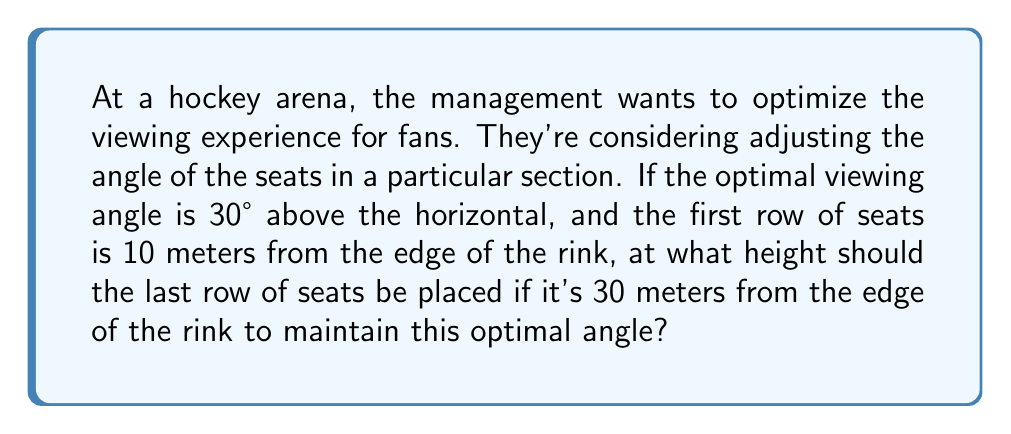Provide a solution to this math problem. Let's approach this step-by-step:

1) We can model this situation using a right triangle, where:
   - The base of the triangle is the horizontal distance from the first row to the last row
   - The height of the triangle is the vertical distance we're trying to find
   - The angle between the base and the hypotenuse is our optimal viewing angle

2) We know:
   - The optimal angle is 30°
   - The distance from the rink to the first row is 10 meters
   - The distance from the rink to the last row is 30 meters

3) The length of the base of our triangle is:
   $30 - 10 = 20$ meters

4) We can use the tangent function to find the height. In a right triangle:

   $\tan(\theta) = \frac{\text{opposite}}{\text{adjacent}} = \frac{\text{height}}{\text{base}}$

5) Substituting our known values:

   $\tan(30°) = \frac{h}{20}$

6) We know that $\tan(30°) = \frac{1}{\sqrt{3}}$, so:

   $\frac{1}{\sqrt{3}} = \frac{h}{20}$

7) Solving for h:

   $h = 20 \cdot \frac{1}{\sqrt{3}} = \frac{20}{\sqrt{3}}$

8) Simplifying:

   $h = \frac{20\sqrt{3}}{3} \approx 11.55$ meters

Therefore, the last row of seats should be approximately 11.55 meters higher than the first row to maintain the optimal viewing angle.
Answer: The height of the last row of seats should be $\frac{20\sqrt{3}}{3}$ meters (approximately 11.55 meters) above the level of the first row. 